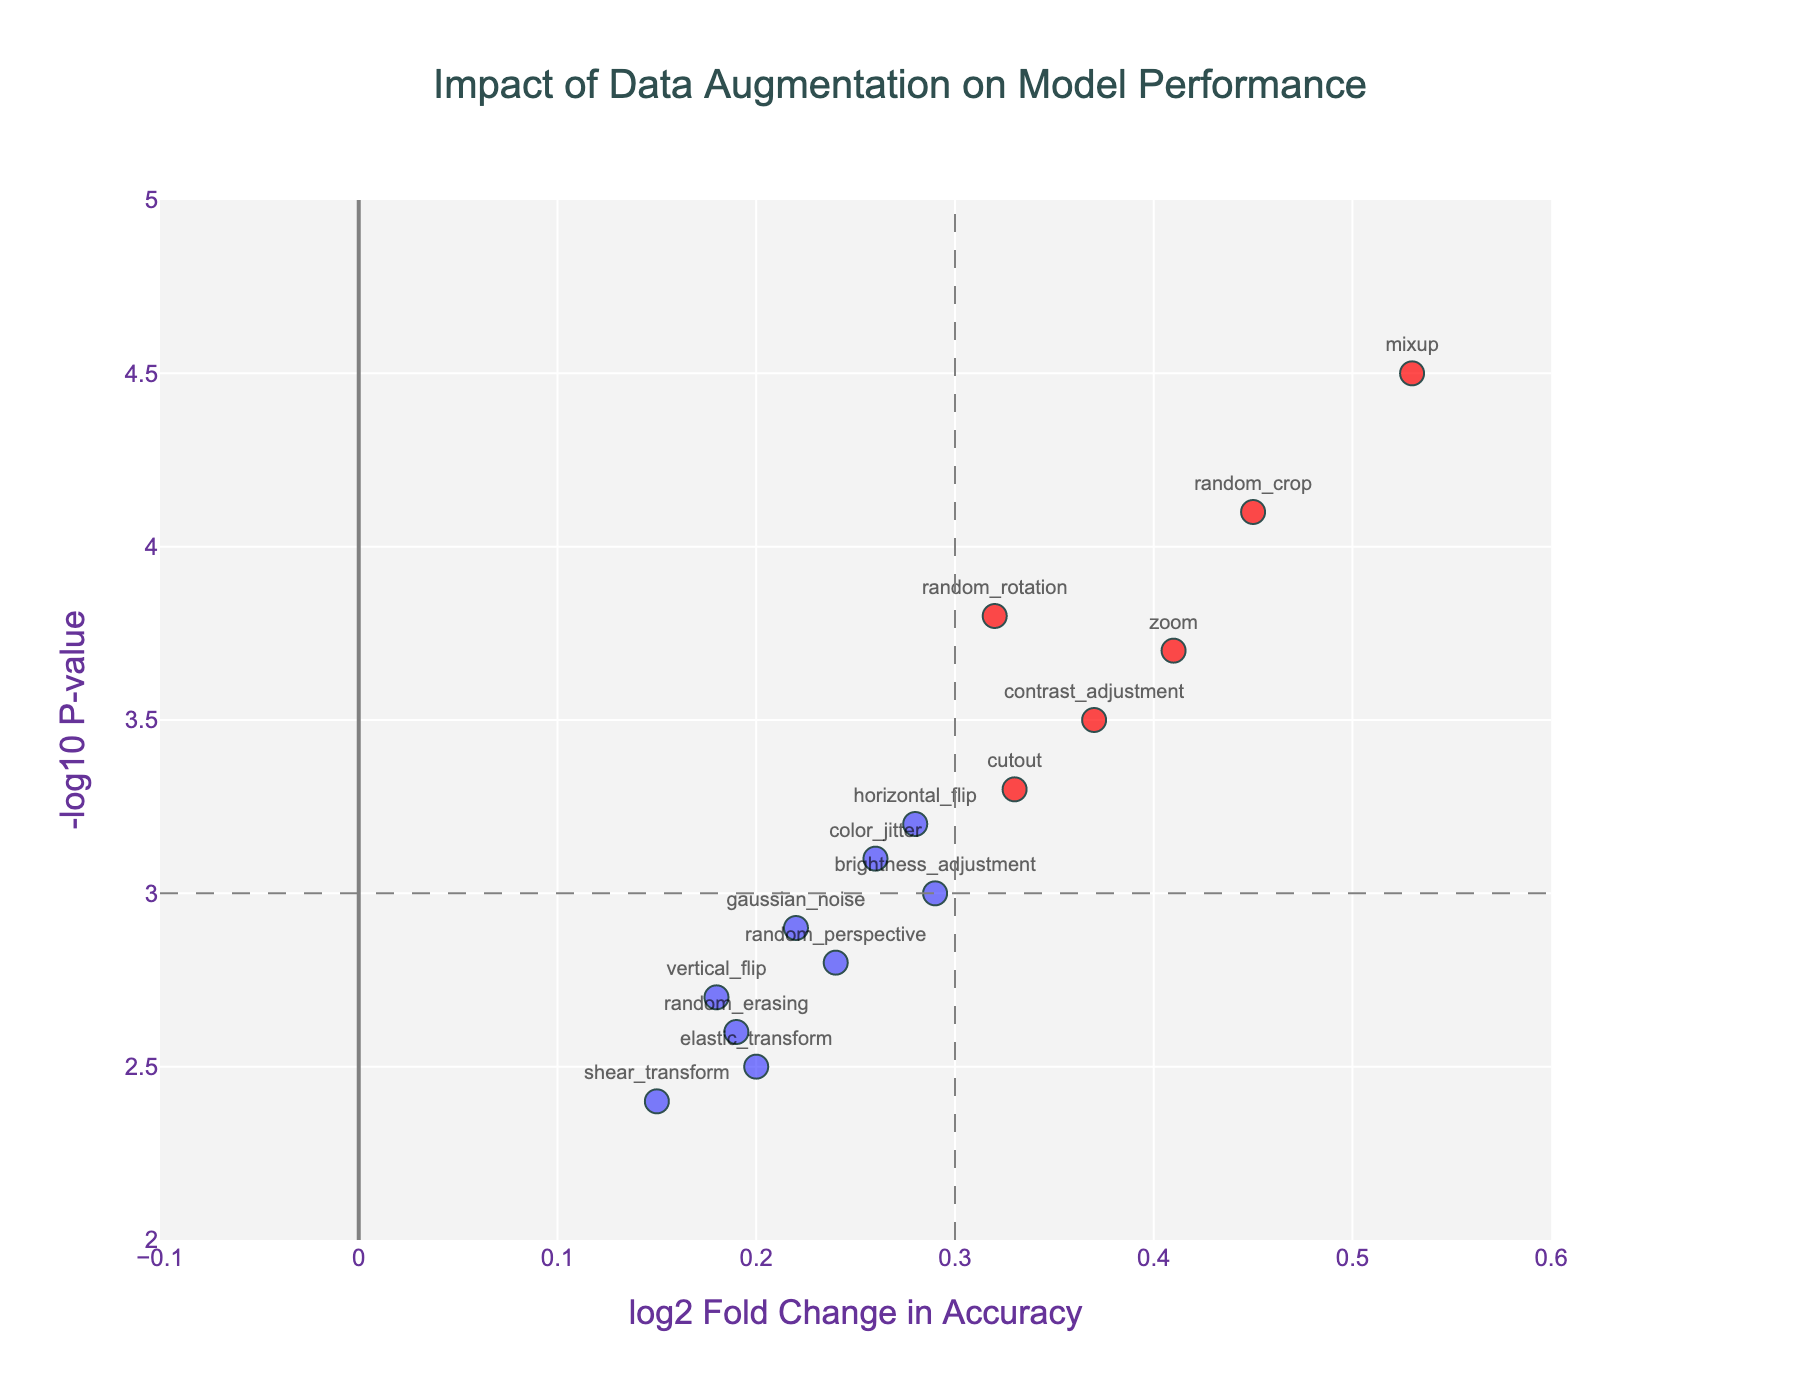what is the title of the plot? The title is prominently displayed at the top center of the plot, indicating the main focus of the visualization.
Answer: "Impact of Data Augmentation on Model Performance" how many data points have a log2 Fold Change in accuracy greater than 0.3? Count the data points to the right of the vertical line at log2 Fold Change = 0.3.
Answer: 6 which data augmentation technique has the highest -log10 P-value? Identify the highest point on the y-axis and read the corresponding technique label.
Answer: mixup which data augmentation techniques are above both the fold change and p-value thresholds? Look for points located above the horizontal line at -log10 P-value = 3 and to the right of the vertical line at log2 Fold Change = 0.3.
Answer: random_crop, mixup, zoom what is the log2 Fold Change in accuracy and -log10 P-value for gaussian noise? Read the coordinates of the point labeled "gaussian_noise" on the plot.
Answer: 0.22, 2.9 do any techniques have a negative log2 Fold Change in accuracy? Check if there are any points left of the vertical line at log2 Fold Change = 0.
Answer: No which data augmentation technique has the smallest -log10 P-value? Identify the lowest point on the y-axis and read the corresponding technique label.
Answer: shear_transform between cutout and horizontal flip, which has a higher -log10 P-value? Compare the y-values of the points labeled "cutout" and "horizontal_flip".
Answer: cutout how many techniques show significant impact according to the thresholds? Count the number of points above the horizontal line at -log10 P-value = 3 and outside the vertical lines at log2 Fold Change = ±0.3.
Answer: 5 how is the effective range of log2 Fold Change in accuracy represented in the plot? Observe the x-axis range of the plot to determine the covered range.
Answer: -0.1 to 0.6 